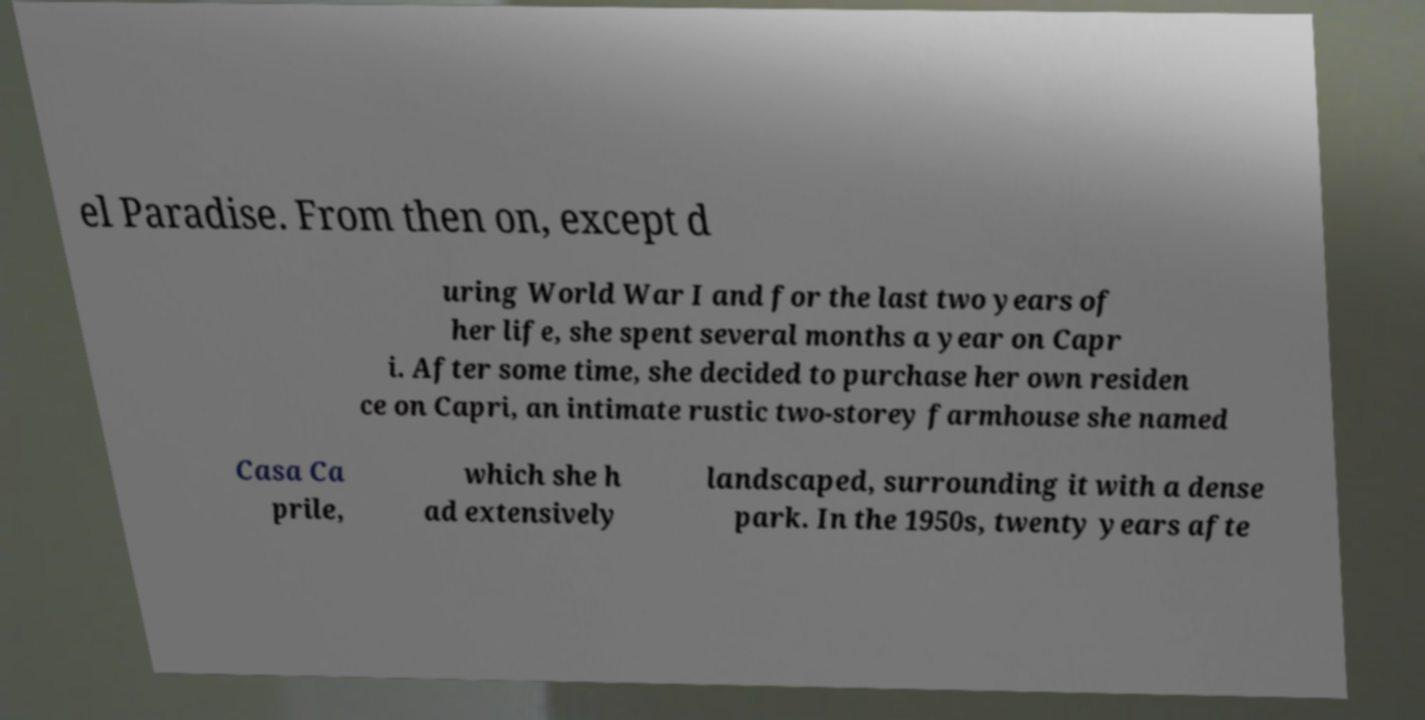For documentation purposes, I need the text within this image transcribed. Could you provide that? el Paradise. From then on, except d uring World War I and for the last two years of her life, she spent several months a year on Capr i. After some time, she decided to purchase her own residen ce on Capri, an intimate rustic two-storey farmhouse she named Casa Ca prile, which she h ad extensively landscaped, surrounding it with a dense park. In the 1950s, twenty years afte 